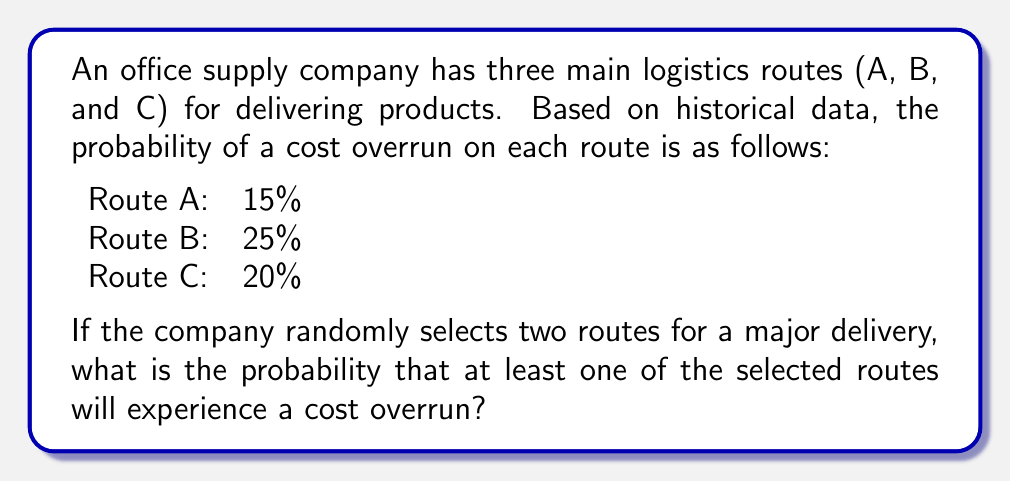Can you solve this math problem? Let's approach this step-by-step:

1) First, we need to calculate the probability of the complement event: neither of the two selected routes experiencing a cost overrun.

2) The probability of a route not experiencing a cost overrun is:
   Route A: $1 - 0.15 = 0.85$
   Route B: $1 - 0.25 = 0.75$
   Route C: $1 - 0.20 = 0.80$

3) There are three possible combinations of two routes:
   A and B, A and C, B and C

4) Let's calculate the probability of no overrun for each combination:
   A and B: $0.85 \times 0.75 = 0.6375$
   A and C: $0.85 \times 0.80 = 0.6800$
   B and C: $0.75 \times 0.80 = 0.6000$

5) The probability of selecting each combination is $\frac{1}{3}$, so the total probability of no overrun is:

   $$P(\text{no overrun}) = \frac{1}{3}(0.6375 + 0.6800 + 0.6000) = 0.6392$$

6) Therefore, the probability of at least one route experiencing a cost overrun is:

   $$P(\text{at least one overrun}) = 1 - P(\text{no overrun}) = 1 - 0.6392 = 0.3608$$

7) Converting to a percentage: $0.3608 \times 100\% = 36.08\%$
Answer: 36.08% 